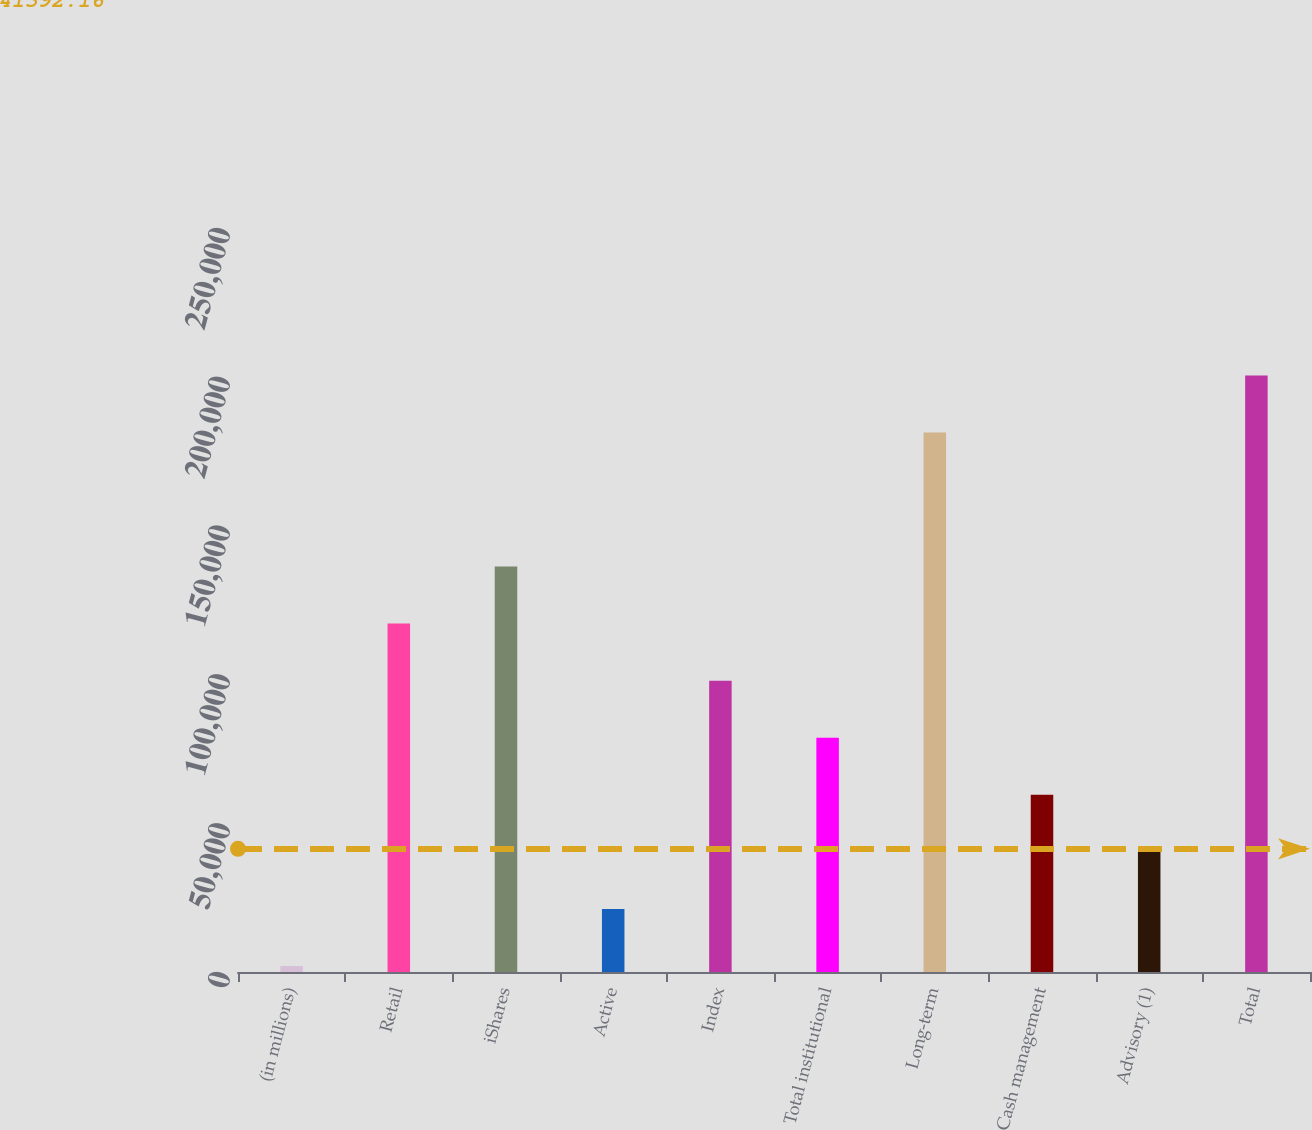Convert chart to OTSL. <chart><loc_0><loc_0><loc_500><loc_500><bar_chart><fcel>(in millions)<fcel>Retail<fcel>iShares<fcel>Active<fcel>Index<fcel>Total institutional<fcel>Long-term<fcel>Cash management<fcel>Advisory (1)<fcel>Total<nl><fcel>2014<fcel>117071<fcel>136247<fcel>21190.2<fcel>97895<fcel>78718.8<fcel>181253<fcel>59542.6<fcel>40366.4<fcel>200429<nl></chart> 